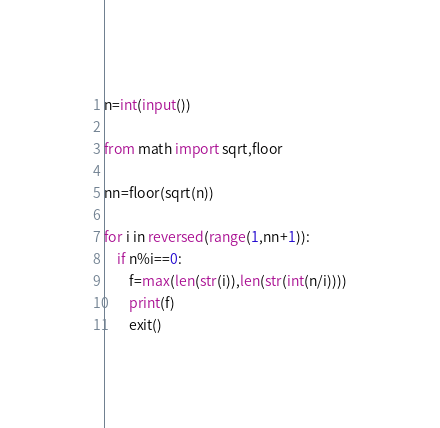<code> <loc_0><loc_0><loc_500><loc_500><_Python_>n=int(input())

from math import sqrt,floor

nn=floor(sqrt(n))

for i in reversed(range(1,nn+1)):
    if n%i==0:
        f=max(len(str(i)),len(str(int(n/i))))
        print(f)
        exit()</code> 